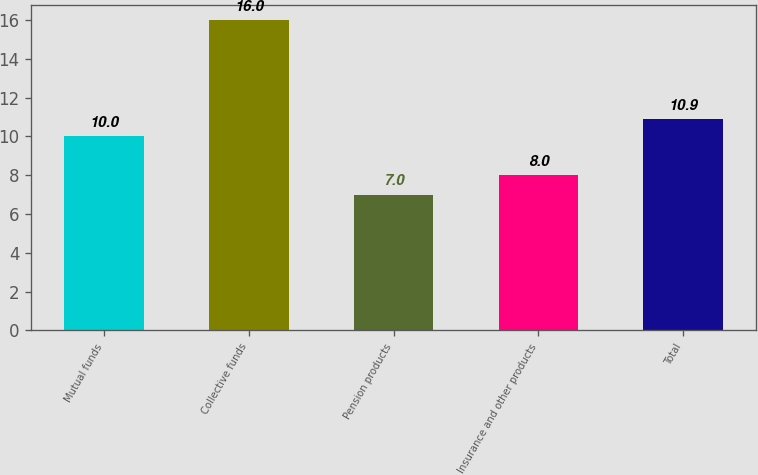<chart> <loc_0><loc_0><loc_500><loc_500><bar_chart><fcel>Mutual funds<fcel>Collective funds<fcel>Pension products<fcel>Insurance and other products<fcel>Total<nl><fcel>10<fcel>16<fcel>7<fcel>8<fcel>10.9<nl></chart> 